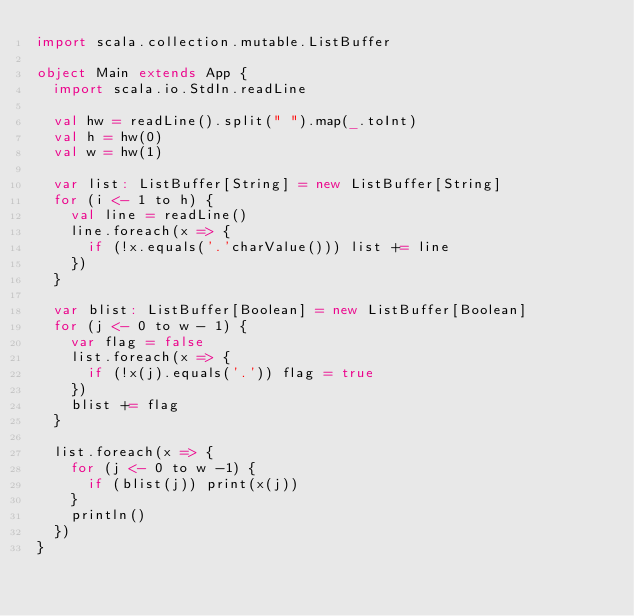<code> <loc_0><loc_0><loc_500><loc_500><_Scala_>import scala.collection.mutable.ListBuffer

object Main extends App {
  import scala.io.StdIn.readLine

  val hw = readLine().split(" ").map(_.toInt)
  val h = hw(0)
  val w = hw(1)

  var list: ListBuffer[String] = new ListBuffer[String]
  for (i <- 1 to h) {
    val line = readLine()
    line.foreach(x => {
      if (!x.equals('.'charValue())) list += line
    })
  }

  var blist: ListBuffer[Boolean] = new ListBuffer[Boolean]
  for (j <- 0 to w - 1) {
    var flag = false
    list.foreach(x => {
      if (!x(j).equals('.')) flag = true
    })
    blist += flag
  }

  list.foreach(x => {
    for (j <- 0 to w -1) {
      if (blist(j)) print(x(j))
    }
    println()
  })
}</code> 